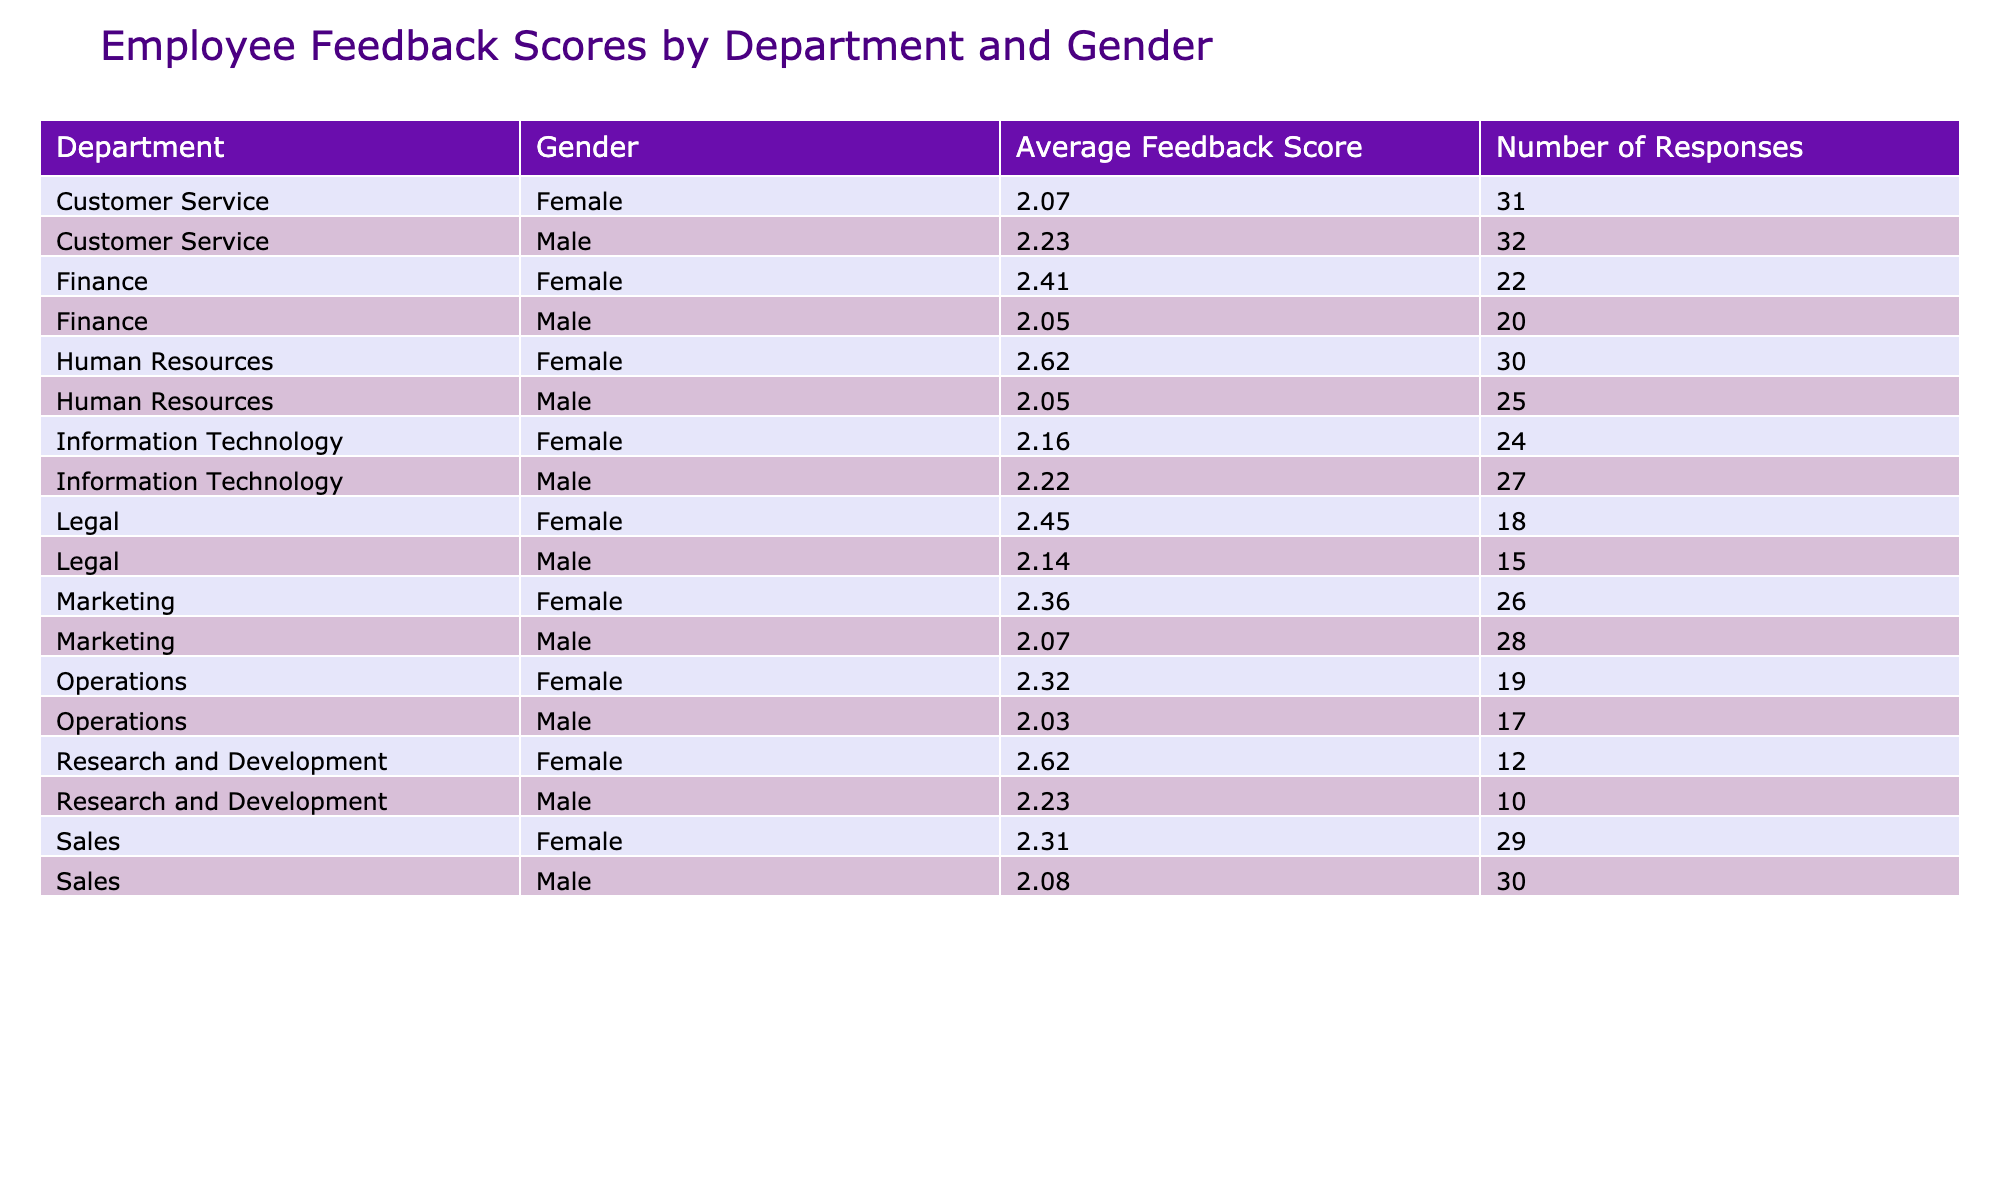What is the average feedback score for the Human Resources department? The table shows that the average feedback score for the Human Resources department is 4.5 for males and 4.8 for females. To find the overall average, we calculate the total weighted score: (4.5 * 25 + 4.8 * 30) / (25 + 30) = (112.5 + 144) / 55 = 4.68.
Answer: 4.68 Which department received the lowest average feedback score? By examining the table, the department with the lowest average feedback score is Marketing, which has 4.0 for males and 4.9 for females. The average score is calculated as (4.0 * 28 + 4.9 * 26) / (28 + 26) = (112 + 127.4) / 54 = 4.43. Departments with a higher score are thus more favorable.
Answer: Marketing Did the Female employees in Sales give a higher feedback score than the Male employees? According to the table, Female employees in Sales scored 4.7 while Male employees scored 4.1. Clearly, 4.7 is greater than 4.1, indicating that Female employees rated their experience higher than Male employees in the Sales department.
Answer: Yes What is the difference in average feedback scores between males and females in the Finance department? Referring to the table, Male employees in Finance have an average score of 4.3, while Females have a score of 4.6. To find the difference, we calculate 4.6 - 4.3 = 0.3. Hence, Female employees have a higher average score by 0.3.
Answer: 0.3 Do the feedback scores for Male and Female employees in Information Technology indicate fairness? In the Information Technology department, Males scored 4.2 and Females scored 4.6. If fairness is defined as equal scores, the scores indicate a disparity favoring Females. Therefore, the feedback scores suggest a lack of fairness between genders in this department.
Answer: No 